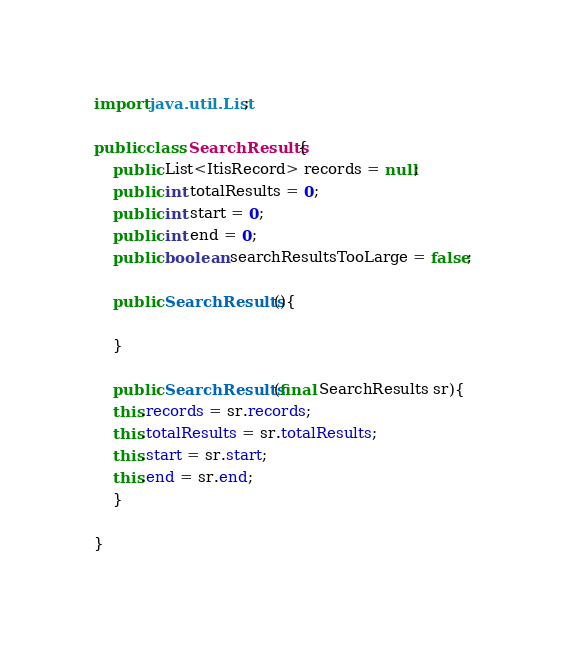<code> <loc_0><loc_0><loc_500><loc_500><_Java_>import java.util.List;

public class SearchResults{
    public List<ItisRecord> records = null;
    public int totalResults = 0;
    public int start = 0;
    public int end = 0;
    public boolean searchResultsTooLarge = false;

    public SearchResults(){

    }

    public SearchResults(final SearchResults sr){
	this.records = sr.records;
	this.totalResults = sr.totalResults;
	this.start = sr.start;
	this.end = sr.end;
    }

}
</code> 